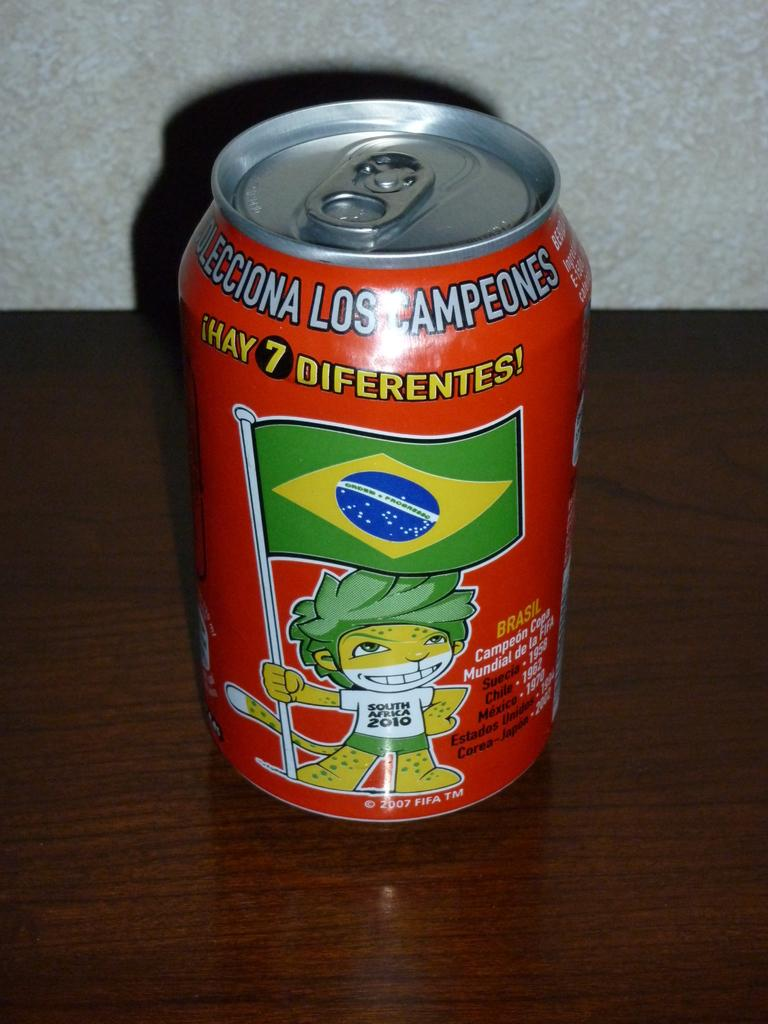<image>
Write a terse but informative summary of the picture. A canned beverage is printed with the phrase "hay 7 diferentes!" 